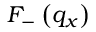Convert formula to latex. <formula><loc_0><loc_0><loc_500><loc_500>{ { F } _ { - } } \left ( { { q } _ { x } } \right )</formula> 